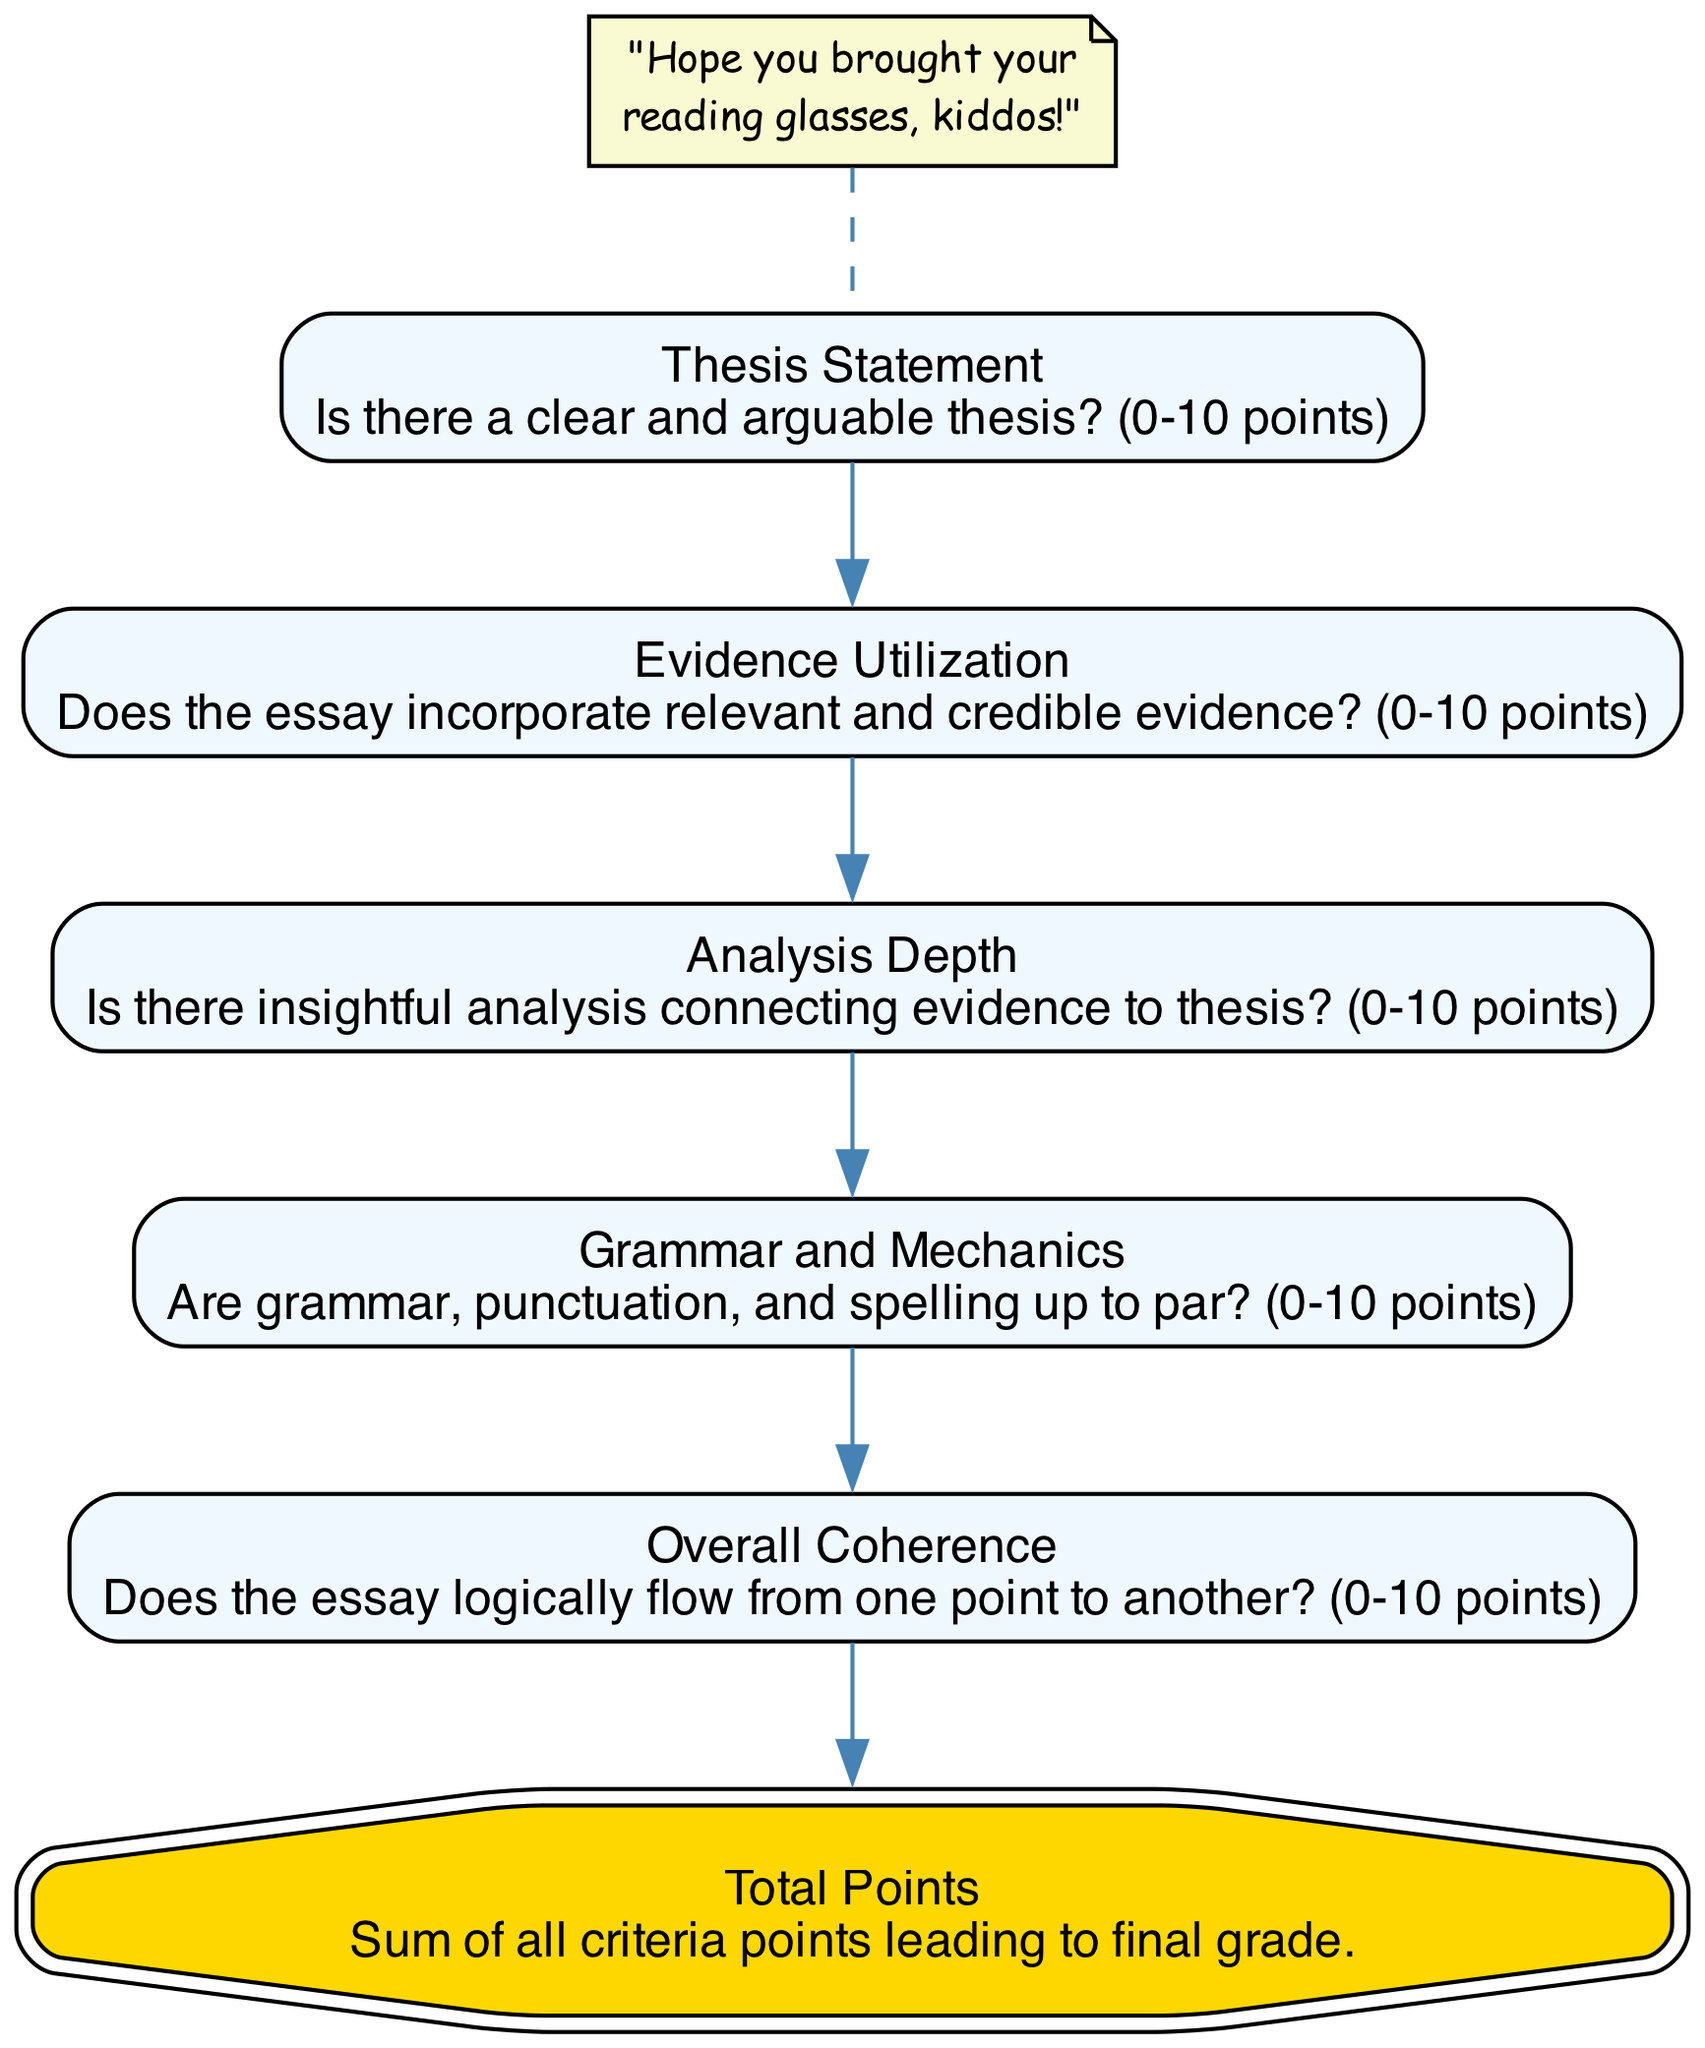What is the maximum score for the Thesis Statement? The maximum score for the Thesis Statement is indicated in the diagram, which states that it can receive between 0-10 points. Thus, the maximum score is 10 points.
Answer: 10 points How many criteria are there before reaching the Total Points node? By counting the nodes leading up to the Total Points node, there are five criteria: Thesis Statement, Evidence Utilization, Analysis Depth, Grammar and Mechanics, and Overall Coherence, totaling to 5 criteria.
Answer: 5 What comes directly after Analysis Depth in the flow? Following Analysis Depth in the flow chart, the next node is Grammar and Mechanics, indicating the sequence of the grading criteria.
Answer: Grammar and Mechanics What is the purpose of the Total Points node? The Total Points node serves to summarize the sum of all criteria points, indicating its role in leading to the final grade for the essay.
Answer: Final grade Which element has a description mentioning "credible evidence"? The element that includes the term "credible evidence" in its description is Evidence Utilization, which focuses on the incorporation of relevant and credible evidence in the essay.
Answer: Evidence Utilization What color is the Total Points node? The Total Points node is highlighted with a gold color, specifically noted in the diagram as having a fill color of '#FFD700'.
Answer: Gold 